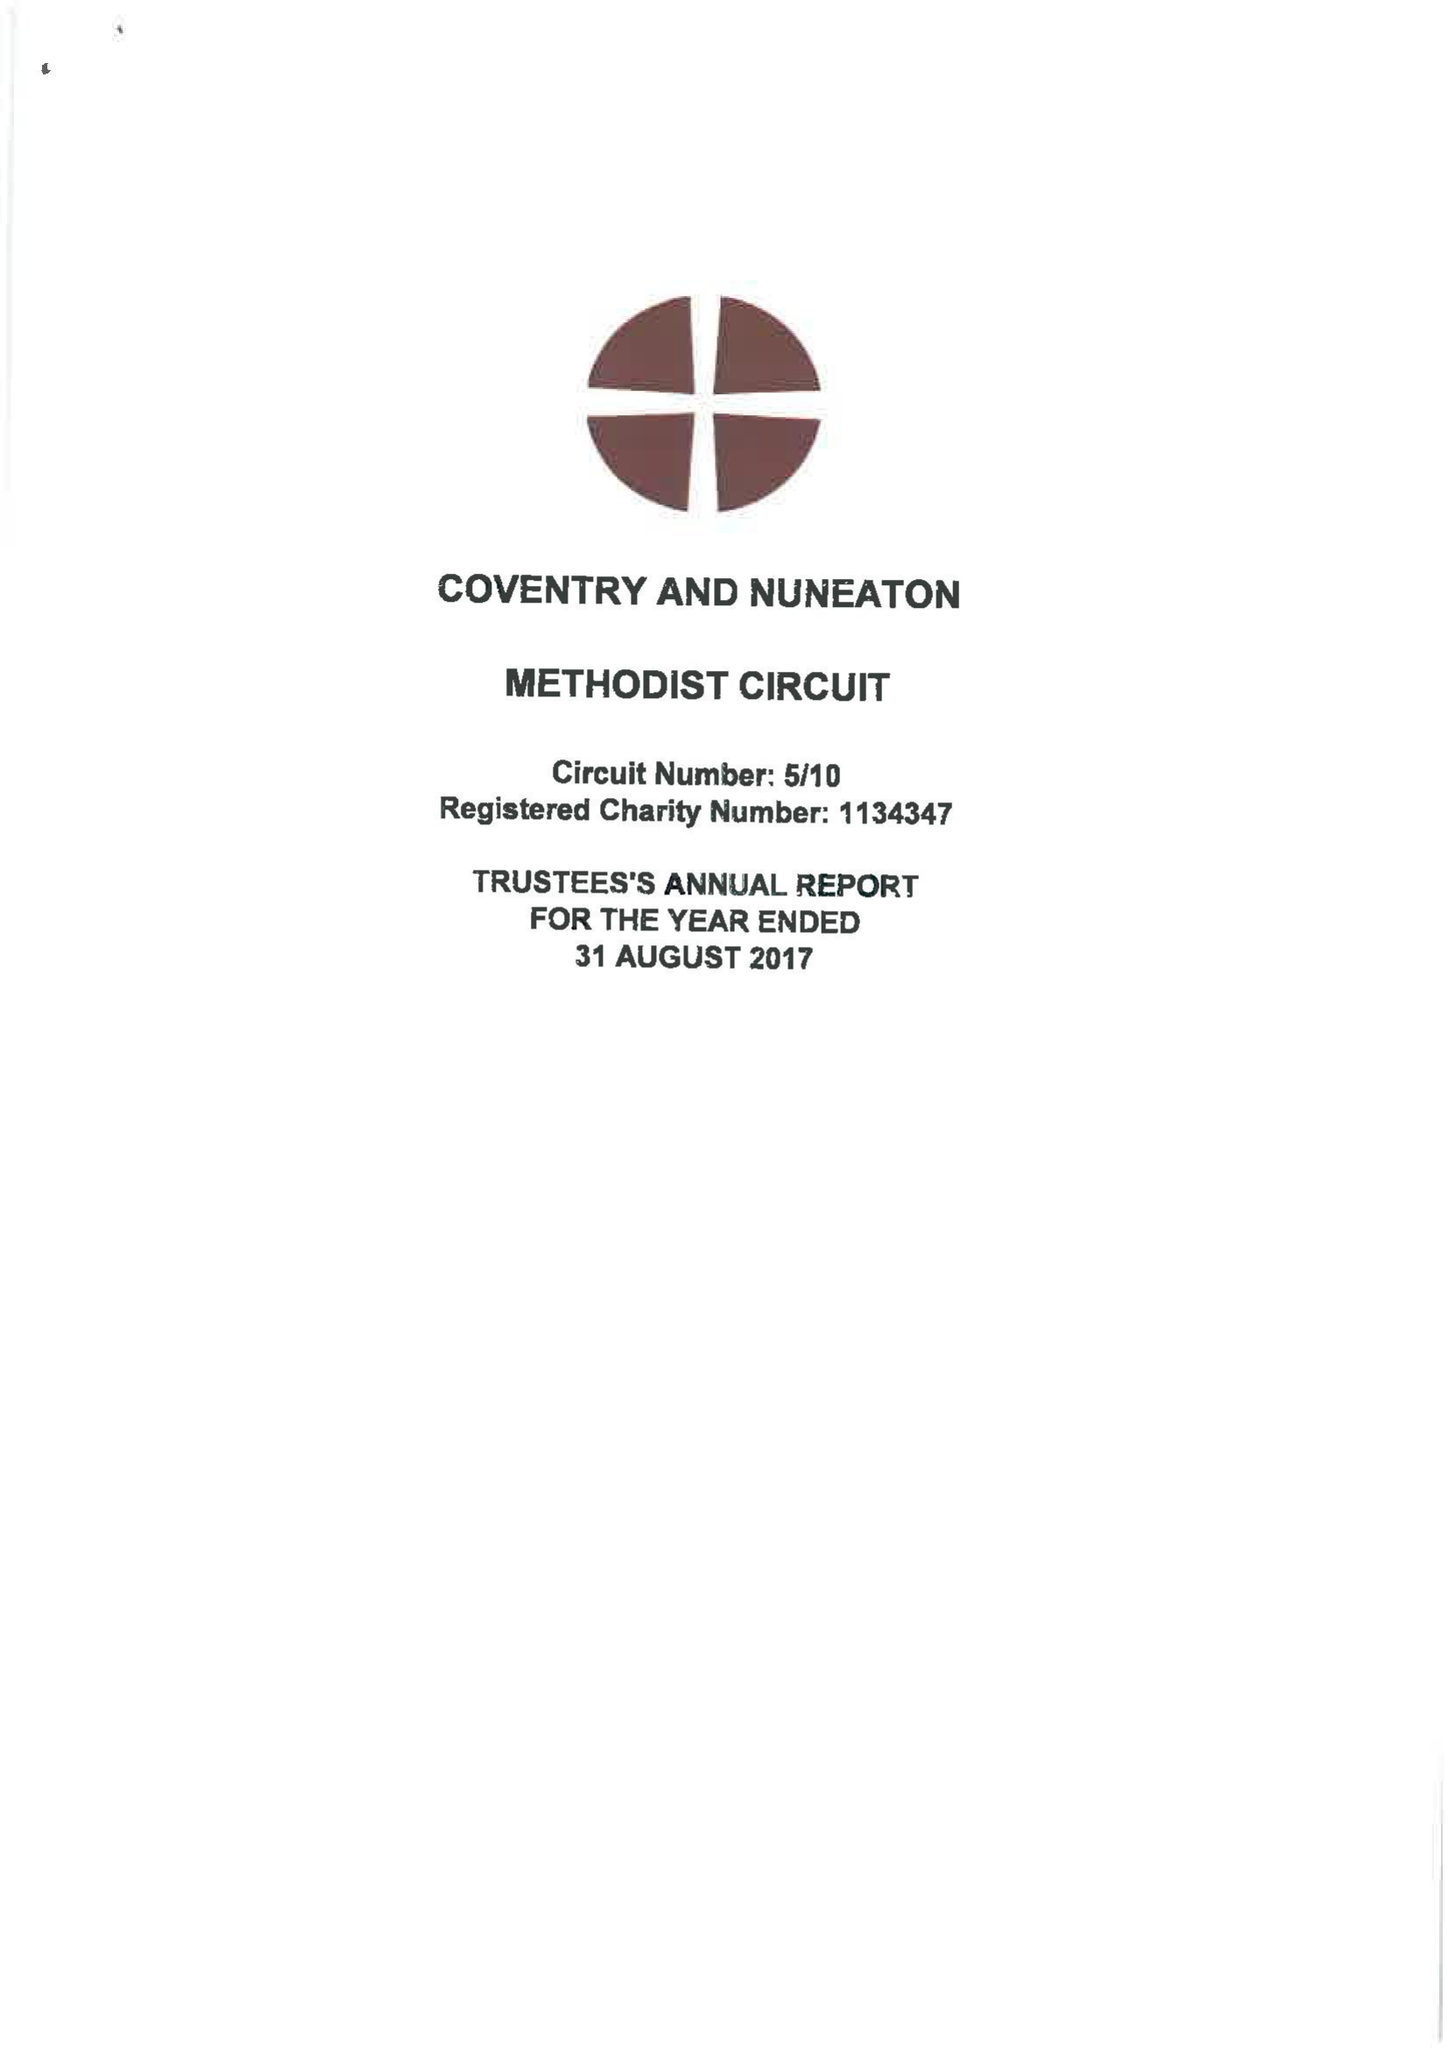What is the value for the income_annually_in_british_pounds?
Answer the question using a single word or phrase. 828066.00 